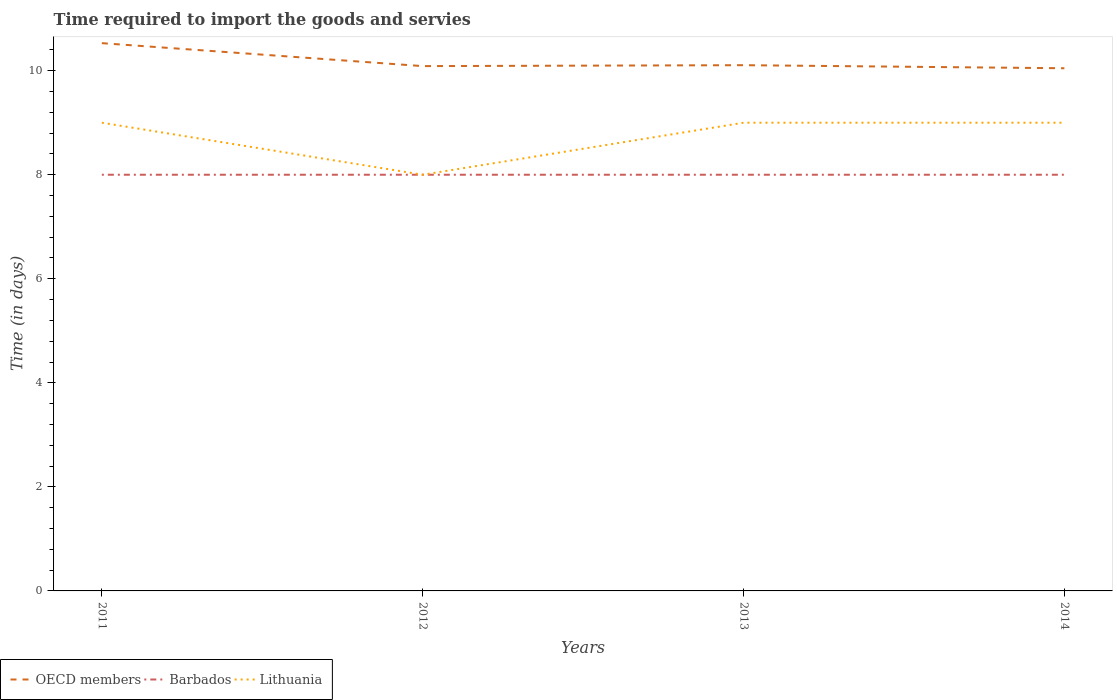Is the number of lines equal to the number of legend labels?
Provide a succinct answer. Yes. Across all years, what is the maximum number of days required to import the goods and services in Lithuania?
Ensure brevity in your answer.  8. What is the total number of days required to import the goods and services in Lithuania in the graph?
Your answer should be very brief. -1. What is the difference between the highest and the second highest number of days required to import the goods and services in Lithuania?
Provide a short and direct response. 1. How many years are there in the graph?
Give a very brief answer. 4. Does the graph contain grids?
Your answer should be compact. No. Where does the legend appear in the graph?
Ensure brevity in your answer.  Bottom left. What is the title of the graph?
Offer a terse response. Time required to import the goods and servies. Does "Cameroon" appear as one of the legend labels in the graph?
Give a very brief answer. No. What is the label or title of the Y-axis?
Make the answer very short. Time (in days). What is the Time (in days) in OECD members in 2011?
Your answer should be very brief. 10.53. What is the Time (in days) in OECD members in 2012?
Provide a succinct answer. 10.09. What is the Time (in days) of Barbados in 2012?
Make the answer very short. 8. What is the Time (in days) of OECD members in 2013?
Make the answer very short. 10.11. What is the Time (in days) of OECD members in 2014?
Give a very brief answer. 10.05. What is the Time (in days) of Barbados in 2014?
Provide a short and direct response. 8. What is the Time (in days) in Lithuania in 2014?
Provide a short and direct response. 9. Across all years, what is the maximum Time (in days) in OECD members?
Your answer should be very brief. 10.53. Across all years, what is the maximum Time (in days) of Barbados?
Give a very brief answer. 8. Across all years, what is the maximum Time (in days) of Lithuania?
Offer a terse response. 9. Across all years, what is the minimum Time (in days) in OECD members?
Your answer should be very brief. 10.05. What is the total Time (in days) in OECD members in the graph?
Give a very brief answer. 40.77. What is the total Time (in days) of Lithuania in the graph?
Keep it short and to the point. 35. What is the difference between the Time (in days) of OECD members in 2011 and that in 2012?
Keep it short and to the point. 0.44. What is the difference between the Time (in days) in Barbados in 2011 and that in 2012?
Your answer should be compact. 0. What is the difference between the Time (in days) of Lithuania in 2011 and that in 2012?
Make the answer very short. 1. What is the difference between the Time (in days) of OECD members in 2011 and that in 2013?
Make the answer very short. 0.42. What is the difference between the Time (in days) of Lithuania in 2011 and that in 2013?
Your answer should be very brief. 0. What is the difference between the Time (in days) in OECD members in 2011 and that in 2014?
Offer a terse response. 0.48. What is the difference between the Time (in days) in Lithuania in 2011 and that in 2014?
Keep it short and to the point. 0. What is the difference between the Time (in days) of OECD members in 2012 and that in 2013?
Offer a terse response. -0.02. What is the difference between the Time (in days) of Barbados in 2012 and that in 2013?
Ensure brevity in your answer.  0. What is the difference between the Time (in days) in Lithuania in 2012 and that in 2013?
Ensure brevity in your answer.  -1. What is the difference between the Time (in days) of OECD members in 2012 and that in 2014?
Offer a very short reply. 0.04. What is the difference between the Time (in days) of OECD members in 2013 and that in 2014?
Provide a short and direct response. 0.06. What is the difference between the Time (in days) of Barbados in 2013 and that in 2014?
Ensure brevity in your answer.  0. What is the difference between the Time (in days) in OECD members in 2011 and the Time (in days) in Barbados in 2012?
Make the answer very short. 2.53. What is the difference between the Time (in days) in OECD members in 2011 and the Time (in days) in Lithuania in 2012?
Make the answer very short. 2.53. What is the difference between the Time (in days) in OECD members in 2011 and the Time (in days) in Barbados in 2013?
Your answer should be compact. 2.53. What is the difference between the Time (in days) in OECD members in 2011 and the Time (in days) in Lithuania in 2013?
Provide a succinct answer. 1.53. What is the difference between the Time (in days) in OECD members in 2011 and the Time (in days) in Barbados in 2014?
Offer a terse response. 2.53. What is the difference between the Time (in days) of OECD members in 2011 and the Time (in days) of Lithuania in 2014?
Make the answer very short. 1.53. What is the difference between the Time (in days) of OECD members in 2012 and the Time (in days) of Barbados in 2013?
Keep it short and to the point. 2.09. What is the difference between the Time (in days) in OECD members in 2012 and the Time (in days) in Lithuania in 2013?
Your answer should be very brief. 1.09. What is the difference between the Time (in days) in OECD members in 2012 and the Time (in days) in Barbados in 2014?
Your answer should be very brief. 2.09. What is the difference between the Time (in days) in OECD members in 2012 and the Time (in days) in Lithuania in 2014?
Your response must be concise. 1.09. What is the difference between the Time (in days) in OECD members in 2013 and the Time (in days) in Barbados in 2014?
Offer a terse response. 2.11. What is the difference between the Time (in days) of OECD members in 2013 and the Time (in days) of Lithuania in 2014?
Your answer should be compact. 1.11. What is the difference between the Time (in days) in Barbados in 2013 and the Time (in days) in Lithuania in 2014?
Provide a short and direct response. -1. What is the average Time (in days) in OECD members per year?
Your response must be concise. 10.19. What is the average Time (in days) of Barbados per year?
Offer a terse response. 8. What is the average Time (in days) in Lithuania per year?
Offer a terse response. 8.75. In the year 2011, what is the difference between the Time (in days) of OECD members and Time (in days) of Barbados?
Give a very brief answer. 2.53. In the year 2011, what is the difference between the Time (in days) in OECD members and Time (in days) in Lithuania?
Offer a terse response. 1.53. In the year 2012, what is the difference between the Time (in days) of OECD members and Time (in days) of Barbados?
Your answer should be compact. 2.09. In the year 2012, what is the difference between the Time (in days) in OECD members and Time (in days) in Lithuania?
Make the answer very short. 2.09. In the year 2013, what is the difference between the Time (in days) in OECD members and Time (in days) in Barbados?
Keep it short and to the point. 2.11. In the year 2013, what is the difference between the Time (in days) of OECD members and Time (in days) of Lithuania?
Ensure brevity in your answer.  1.11. In the year 2014, what is the difference between the Time (in days) of OECD members and Time (in days) of Barbados?
Your answer should be very brief. 2.05. In the year 2014, what is the difference between the Time (in days) in OECD members and Time (in days) in Lithuania?
Your response must be concise. 1.05. In the year 2014, what is the difference between the Time (in days) in Barbados and Time (in days) in Lithuania?
Keep it short and to the point. -1. What is the ratio of the Time (in days) in OECD members in 2011 to that in 2012?
Offer a very short reply. 1.04. What is the ratio of the Time (in days) of OECD members in 2011 to that in 2013?
Your answer should be very brief. 1.04. What is the ratio of the Time (in days) of Barbados in 2011 to that in 2013?
Make the answer very short. 1. What is the ratio of the Time (in days) of Lithuania in 2011 to that in 2013?
Offer a terse response. 1. What is the ratio of the Time (in days) of OECD members in 2011 to that in 2014?
Offer a terse response. 1.05. What is the ratio of the Time (in days) in Barbados in 2011 to that in 2014?
Offer a very short reply. 1. What is the ratio of the Time (in days) of Lithuania in 2011 to that in 2014?
Provide a succinct answer. 1. What is the ratio of the Time (in days) in OECD members in 2012 to that in 2013?
Offer a very short reply. 1. What is the ratio of the Time (in days) of Barbados in 2012 to that in 2013?
Make the answer very short. 1. What is the ratio of the Time (in days) of OECD members in 2012 to that in 2014?
Keep it short and to the point. 1. What is the ratio of the Time (in days) of Barbados in 2012 to that in 2014?
Provide a succinct answer. 1. What is the ratio of the Time (in days) of OECD members in 2013 to that in 2014?
Offer a terse response. 1.01. What is the difference between the highest and the second highest Time (in days) of OECD members?
Offer a terse response. 0.42. What is the difference between the highest and the lowest Time (in days) in OECD members?
Your answer should be very brief. 0.48. What is the difference between the highest and the lowest Time (in days) in Barbados?
Give a very brief answer. 0. 